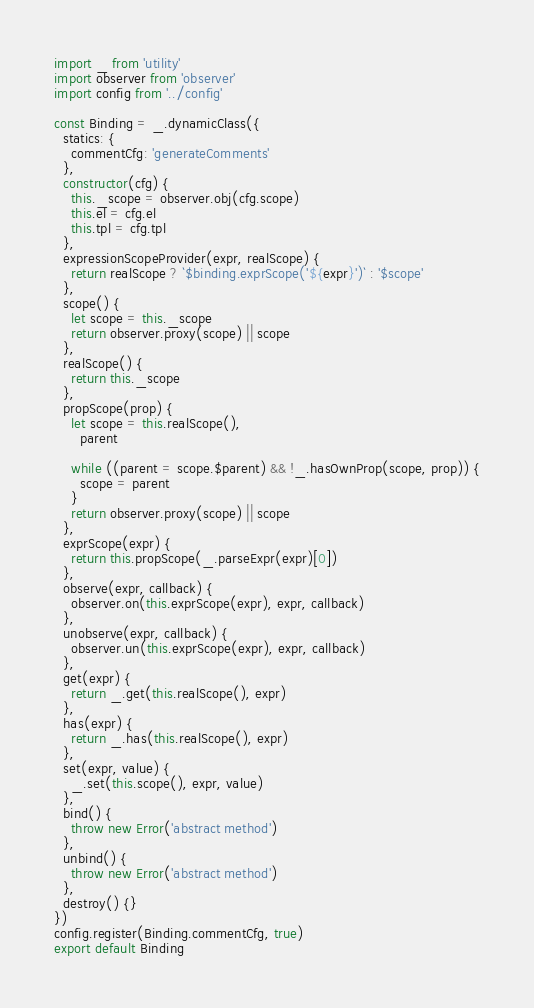Convert code to text. <code><loc_0><loc_0><loc_500><loc_500><_JavaScript_>import _ from 'utility'
import observer from 'observer'
import config from '../config'

const Binding = _.dynamicClass({
  statics: {
    commentCfg: 'generateComments'
  },
  constructor(cfg) {
    this._scope = observer.obj(cfg.scope)
    this.el = cfg.el
    this.tpl = cfg.tpl
  },
  expressionScopeProvider(expr, realScope) {
    return realScope ? `$binding.exprScope('${expr}')` : '$scope'
  },
  scope() {
    let scope = this._scope
    return observer.proxy(scope) || scope
  },
  realScope() {
    return this._scope
  },
  propScope(prop) {
    let scope = this.realScope(),
      parent

    while ((parent = scope.$parent) && !_.hasOwnProp(scope, prop)) {
      scope = parent
    }
    return observer.proxy(scope) || scope
  },
  exprScope(expr) {
    return this.propScope(_.parseExpr(expr)[0])
  },
  observe(expr, callback) {
    observer.on(this.exprScope(expr), expr, callback)
  },
  unobserve(expr, callback) {
    observer.un(this.exprScope(expr), expr, callback)
  },
  get(expr) {
    return _.get(this.realScope(), expr)
  },
  has(expr) {
    return _.has(this.realScope(), expr)
  },
  set(expr, value) {
    _.set(this.scope(), expr, value)
  },
  bind() {
    throw new Error('abstract method')
  },
  unbind() {
    throw new Error('abstract method')
  },
  destroy() {}
})
config.register(Binding.commentCfg, true)
export default Binding
</code> 